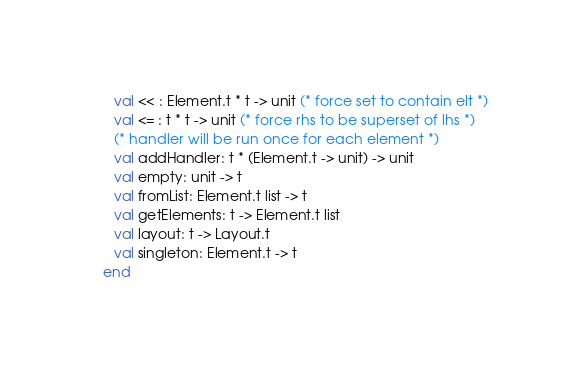<code> <loc_0><loc_0><loc_500><loc_500><_SML_>
      val << : Element.t * t -> unit (* force set to contain elt *)
      val <= : t * t -> unit (* force rhs to be superset of lhs *)
      (* handler will be run once for each element *)
      val addHandler: t * (Element.t -> unit) -> unit
      val empty: unit -> t
      val fromList: Element.t list -> t
      val getElements: t -> Element.t list
      val layout: t -> Layout.t
      val singleton: Element.t -> t
   end
</code> 